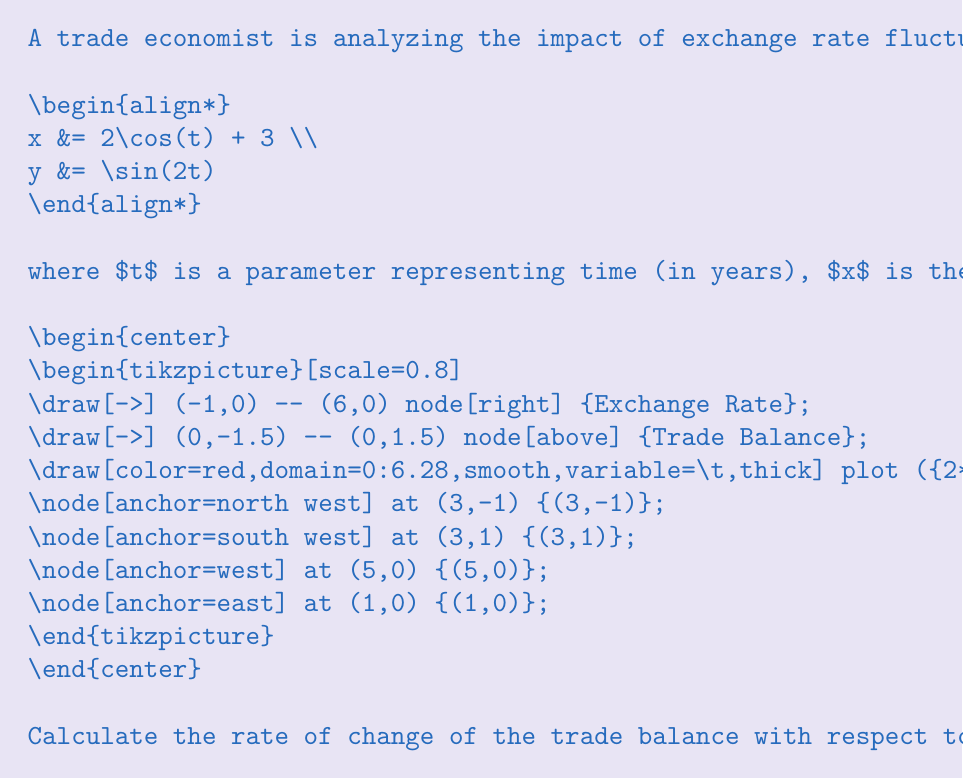What is the answer to this math problem? Let's approach this step-by-step:

1) First, we need to find the minimum value of the exchange rate x.
   $$x = 2\cos(t) + 3$$
   The minimum occurs when $\cos(t) = -1$, so:
   $$x_{min} = 2(-1) + 3 = 1$$

2) Now, we need to find the corresponding t value:
   $$\cos(t) = -1$$
   $$t = \pi$$ (or odd multiples of $\pi$)

3) To find the rate of change of y with respect to x, we need to use the chain rule:
   $$\frac{dy}{dx} = \frac{dy/dt}{dx/dt}$$

4) Let's calculate $\frac{dy}{dt}$ and $\frac{dx}{dt}$:
   $$\frac{dy}{dt} = 2\cos(2t)$$
   $$\frac{dx}{dt} = -2\sin(t)$$

5) Now, we can substitute these into our rate of change equation:
   $$\frac{dy}{dx} = \frac{2\cos(2t)}{-2\sin(t)} = -\frac{\cos(2t)}{\sin(t)}$$

6) We need to evaluate this at $t = \pi$:
   $$\frac{dy}{dx}\bigg|_{t=\pi} = -\frac{\cos(2\pi)}{\sin(\pi)} = -\frac{1}{0}$$

7) This result is undefined, indicating a vertical tangent line on the graph at this point.

8) To find the actual value, we can use L'Hôpital's rule or observe the behavior around this point:
   As we approach $t = \pi$ from either side, $\frac{dy}{dx}$ approaches positive infinity.
Answer: $+\infty$ 